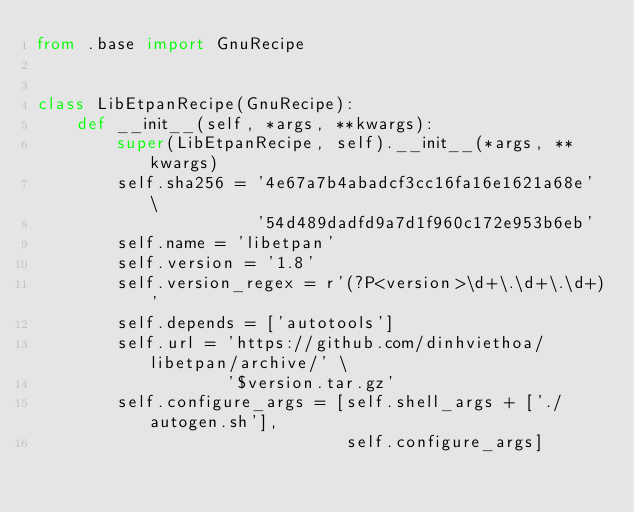Convert code to text. <code><loc_0><loc_0><loc_500><loc_500><_Python_>from .base import GnuRecipe


class LibEtpanRecipe(GnuRecipe):
    def __init__(self, *args, **kwargs):
        super(LibEtpanRecipe, self).__init__(*args, **kwargs)
        self.sha256 = '4e67a7b4abadcf3cc16fa16e1621a68e' \
                      '54d489dadfd9a7d1f960c172e953b6eb'
        self.name = 'libetpan'
        self.version = '1.8'
        self.version_regex = r'(?P<version>\d+\.\d+\.\d+)'
        self.depends = ['autotools']
        self.url = 'https://github.com/dinhviethoa/libetpan/archive/' \
                   '$version.tar.gz'
        self.configure_args = [self.shell_args + ['./autogen.sh'],
                               self.configure_args]
</code> 